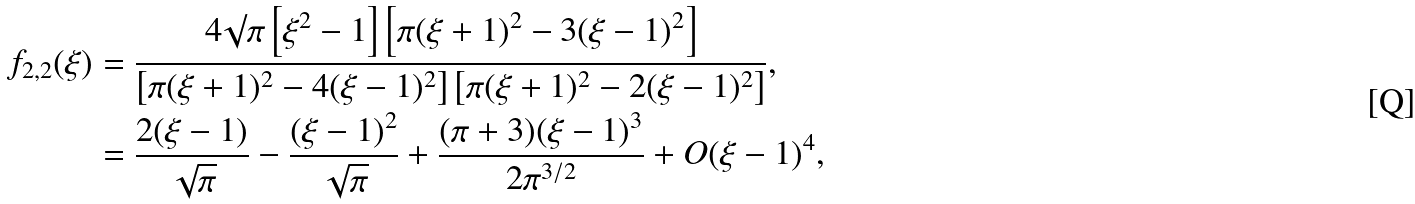Convert formula to latex. <formula><loc_0><loc_0><loc_500><loc_500>f _ { 2 , 2 } ( \xi ) & = \frac { 4 \surd \pi \left [ \xi ^ { 2 } - 1 \right ] \left [ \pi ( \xi + 1 ) ^ { 2 } - 3 ( \xi - 1 ) ^ { 2 } \right ] } { \left [ \pi ( \xi + 1 ) ^ { 2 } - 4 ( \xi - 1 ) ^ { 2 } \right ] \left [ \pi ( \xi + 1 ) ^ { 2 } - 2 ( \xi - 1 ) ^ { 2 } \right ] } , \\ & = \frac { 2 ( \xi - 1 ) } { \sqrt { \pi } } - \frac { ( \xi - 1 ) ^ { 2 } } { \sqrt { \pi } } + \frac { ( \pi + 3 ) ( \xi - 1 ) ^ { 3 } } { 2 \pi ^ { 3 / 2 } } + O ( \xi - 1 ) ^ { 4 } ,</formula> 